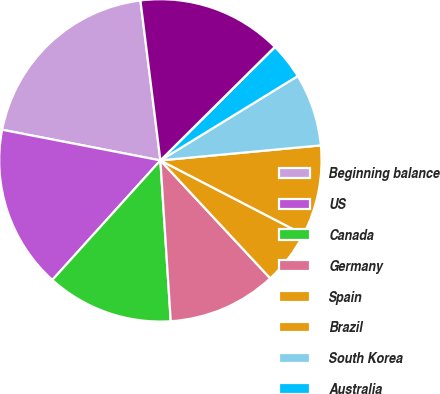<chart> <loc_0><loc_0><loc_500><loc_500><pie_chart><fcel>Beginning balance<fcel>US<fcel>Canada<fcel>Germany<fcel>Spain<fcel>Brazil<fcel>South Korea<fcel>Australia<fcel>UK<fcel>Sweden<nl><fcel>19.98%<fcel>16.35%<fcel>12.72%<fcel>10.91%<fcel>5.46%<fcel>9.09%<fcel>7.28%<fcel>3.65%<fcel>0.02%<fcel>14.54%<nl></chart> 